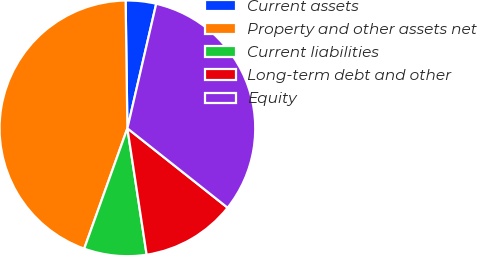Convert chart. <chart><loc_0><loc_0><loc_500><loc_500><pie_chart><fcel>Current assets<fcel>Property and other assets net<fcel>Current liabilities<fcel>Long-term debt and other<fcel>Equity<nl><fcel>3.84%<fcel>44.29%<fcel>7.89%<fcel>11.93%<fcel>32.04%<nl></chart> 